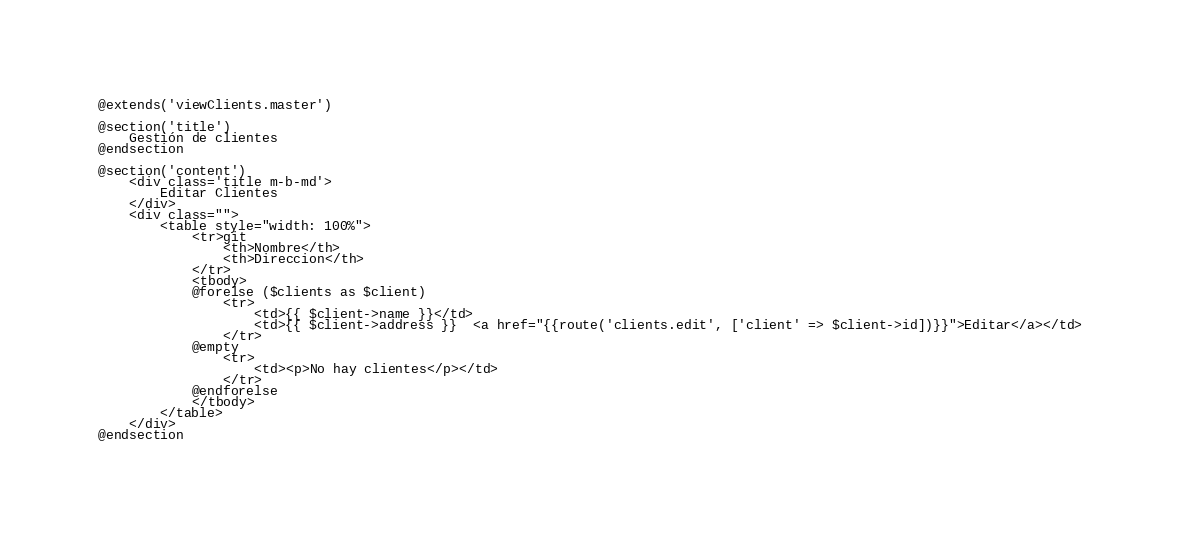<code> <loc_0><loc_0><loc_500><loc_500><_PHP_>@extends('viewClients.master')

@section('title')
    Gestión de clientes
@endsection

@section('content')
    <div class='title m-b-md'>
        Editar Clientes
    </div>
    <div class="">
        <table style="width: 100%">
            <tr>git
                <th>Nombre</th>
                <th>Direccion</th>
            </tr>
            <tbody>
            @forelse ($clients as $client)
                <tr>
                    <td>{{ $client->name }}</td>
                    <td>{{ $client->address }}  <a href="{{route('clients.edit', ['client' => $client->id])}}">Editar</a></td>
                </tr>
            @empty
                <tr>
                    <td><p>No hay clientes</p></td>
                </tr>
            @endforelse
            </tbody>
        </table>
    </div>
@endsection
</code> 